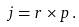<formula> <loc_0><loc_0><loc_500><loc_500>j = r \times p \, .</formula> 